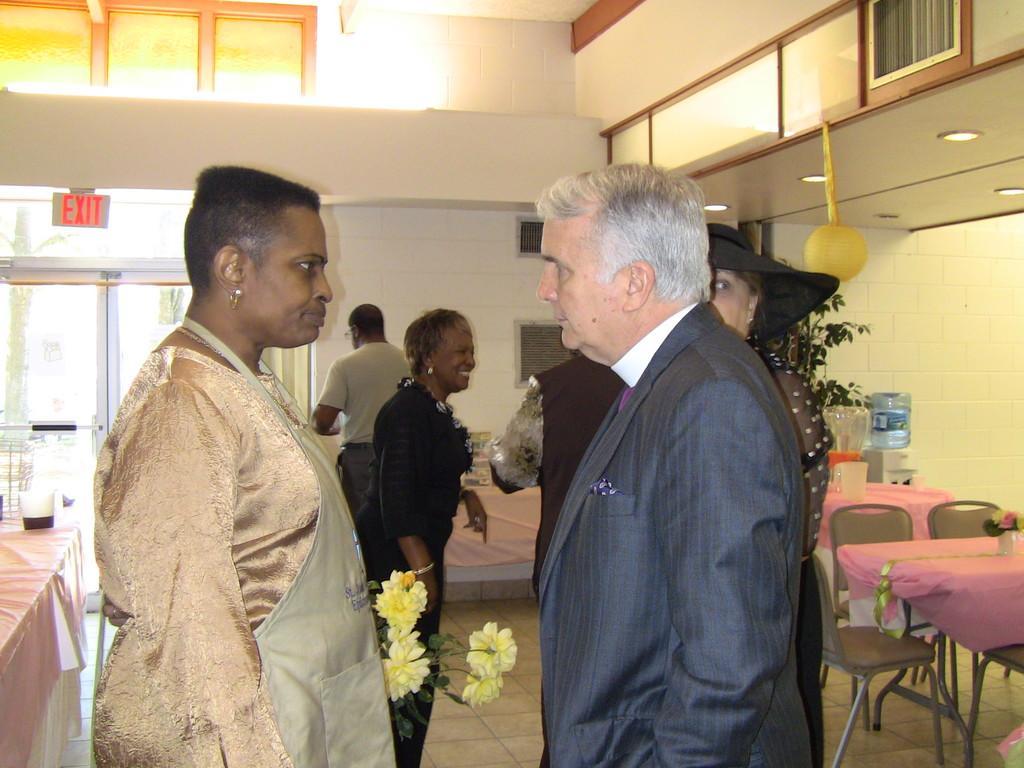In one or two sentences, can you explain what this image depicts? In this image I can see few people standing. To the right there is a table and the chairs. On the table there is a flower vase. At the back ground there is a glass window on the exit board. 